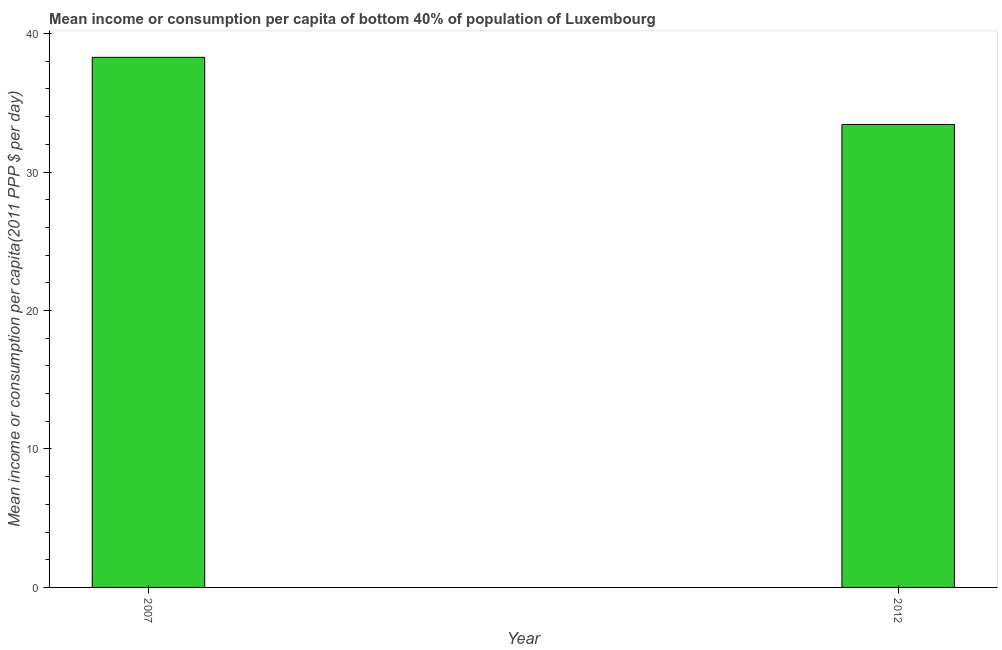Does the graph contain any zero values?
Offer a very short reply. No. What is the title of the graph?
Give a very brief answer. Mean income or consumption per capita of bottom 40% of population of Luxembourg. What is the label or title of the X-axis?
Your answer should be compact. Year. What is the label or title of the Y-axis?
Give a very brief answer. Mean income or consumption per capita(2011 PPP $ per day). What is the mean income or consumption in 2007?
Offer a terse response. 38.29. Across all years, what is the maximum mean income or consumption?
Your response must be concise. 38.29. Across all years, what is the minimum mean income or consumption?
Offer a very short reply. 33.44. What is the sum of the mean income or consumption?
Provide a short and direct response. 71.72. What is the difference between the mean income or consumption in 2007 and 2012?
Provide a short and direct response. 4.85. What is the average mean income or consumption per year?
Your answer should be compact. 35.86. What is the median mean income or consumption?
Provide a succinct answer. 35.86. In how many years, is the mean income or consumption greater than 26 $?
Give a very brief answer. 2. What is the ratio of the mean income or consumption in 2007 to that in 2012?
Offer a terse response. 1.15. Is the mean income or consumption in 2007 less than that in 2012?
Your response must be concise. No. Are all the bars in the graph horizontal?
Your answer should be very brief. No. What is the difference between two consecutive major ticks on the Y-axis?
Provide a short and direct response. 10. What is the Mean income or consumption per capita(2011 PPP $ per day) in 2007?
Offer a terse response. 38.29. What is the Mean income or consumption per capita(2011 PPP $ per day) in 2012?
Your answer should be very brief. 33.44. What is the difference between the Mean income or consumption per capita(2011 PPP $ per day) in 2007 and 2012?
Provide a short and direct response. 4.85. What is the ratio of the Mean income or consumption per capita(2011 PPP $ per day) in 2007 to that in 2012?
Your answer should be very brief. 1.15. 